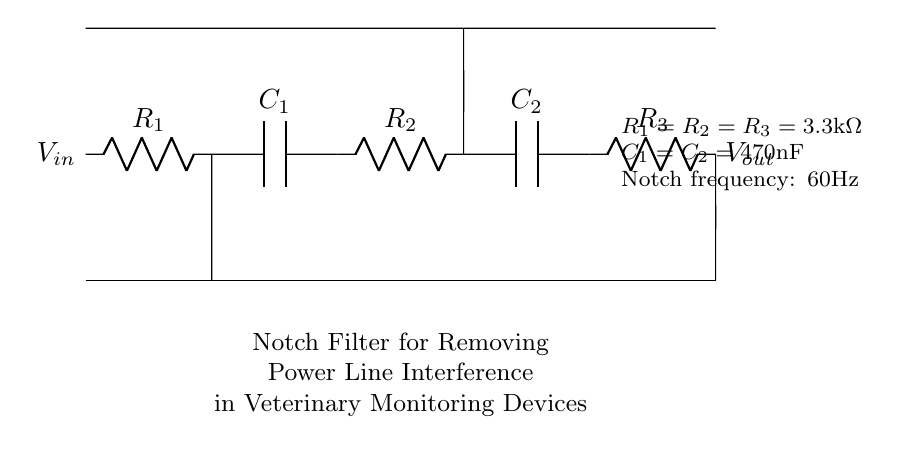What is the input voltage of the circuit? The input voltage, labeled as \(V_{in}\), is specified in the diagram but not given an explicit value. It indicates that the circuit is designed to accept a voltage input.
Answer: \(V_{in}\) What type of filter is this circuit? The circuit is described as a notch filter, which is indicated in the circuit label. A notch filter is specifically designed to eliminate a particular frequency, in this case, to remove power line interference.
Answer: Notch filter What are the resistance values used in the circuit? The values for the resistors are stated in the diagram as \(R_1 = R_2 = R_3 = 3.3\text{k}\Omega\), which indicates that all three resistors have the same resistance value.
Answer: 3.3 kiloohms What is the capacitance value in the circuit? The capacitance values given for both capacitors \(C_1\) and \(C_2\) is \(470\text{nF}\). This indicates the size of the capacitors used in the notch filter design.
Answer: 470 nanofarads What is the notch frequency of this filter circuit? The notch frequency, which defines the frequency that the filter is designed to attenuate, is provided in the description as 60Hz. This specific frequency corresponds to typical power line interference.
Answer: 60 Hz How many capacitors are present in this circuit? The circuit diagram includes two capacitors, \(C_1\) and \(C_2\). The presence of these components is necessary for the notch filter function.
Answer: 2 What are the output terminals labeled as in the circuit? The output terminals are labeled as \(V_{out}\) in the circuit diagram, indicating the voltage that is output from the filter circuit after processing the input signal.
Answer: \(V_{out}\) 